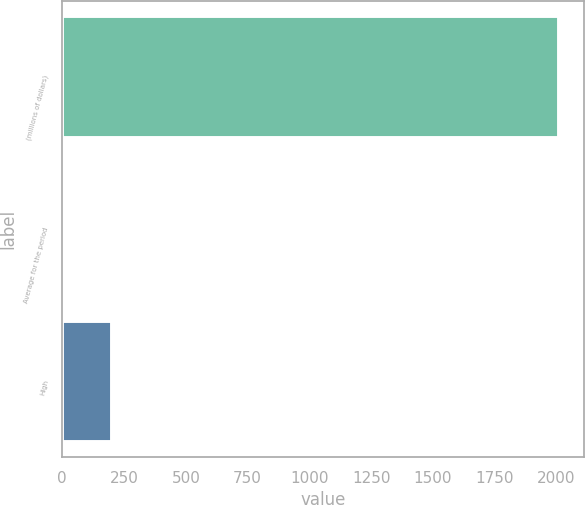Convert chart to OTSL. <chart><loc_0><loc_0><loc_500><loc_500><bar_chart><fcel>(millions of dollars)<fcel>Average for the period<fcel>High<nl><fcel>2012<fcel>1<fcel>202.1<nl></chart> 